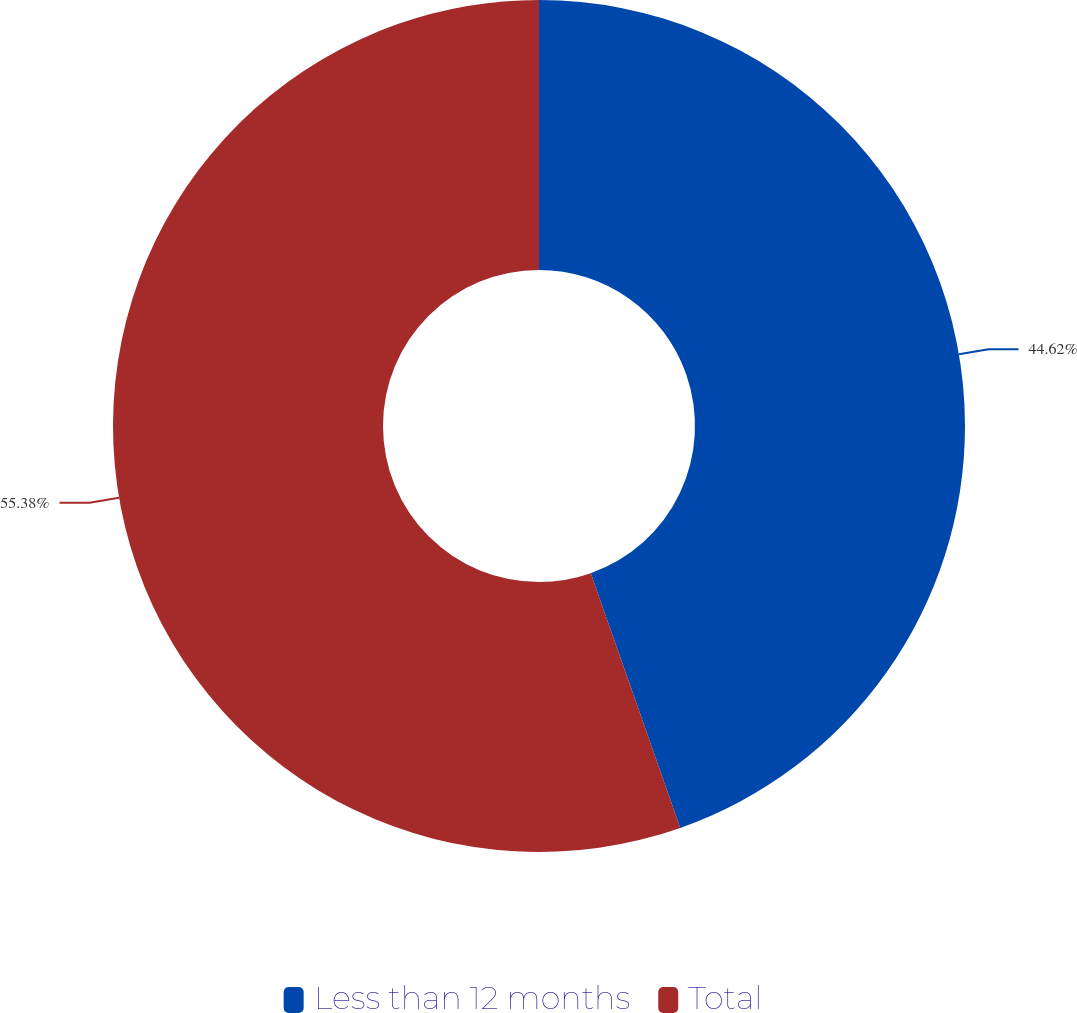<chart> <loc_0><loc_0><loc_500><loc_500><pie_chart><fcel>Less than 12 months<fcel>Total<nl><fcel>44.62%<fcel>55.38%<nl></chart> 